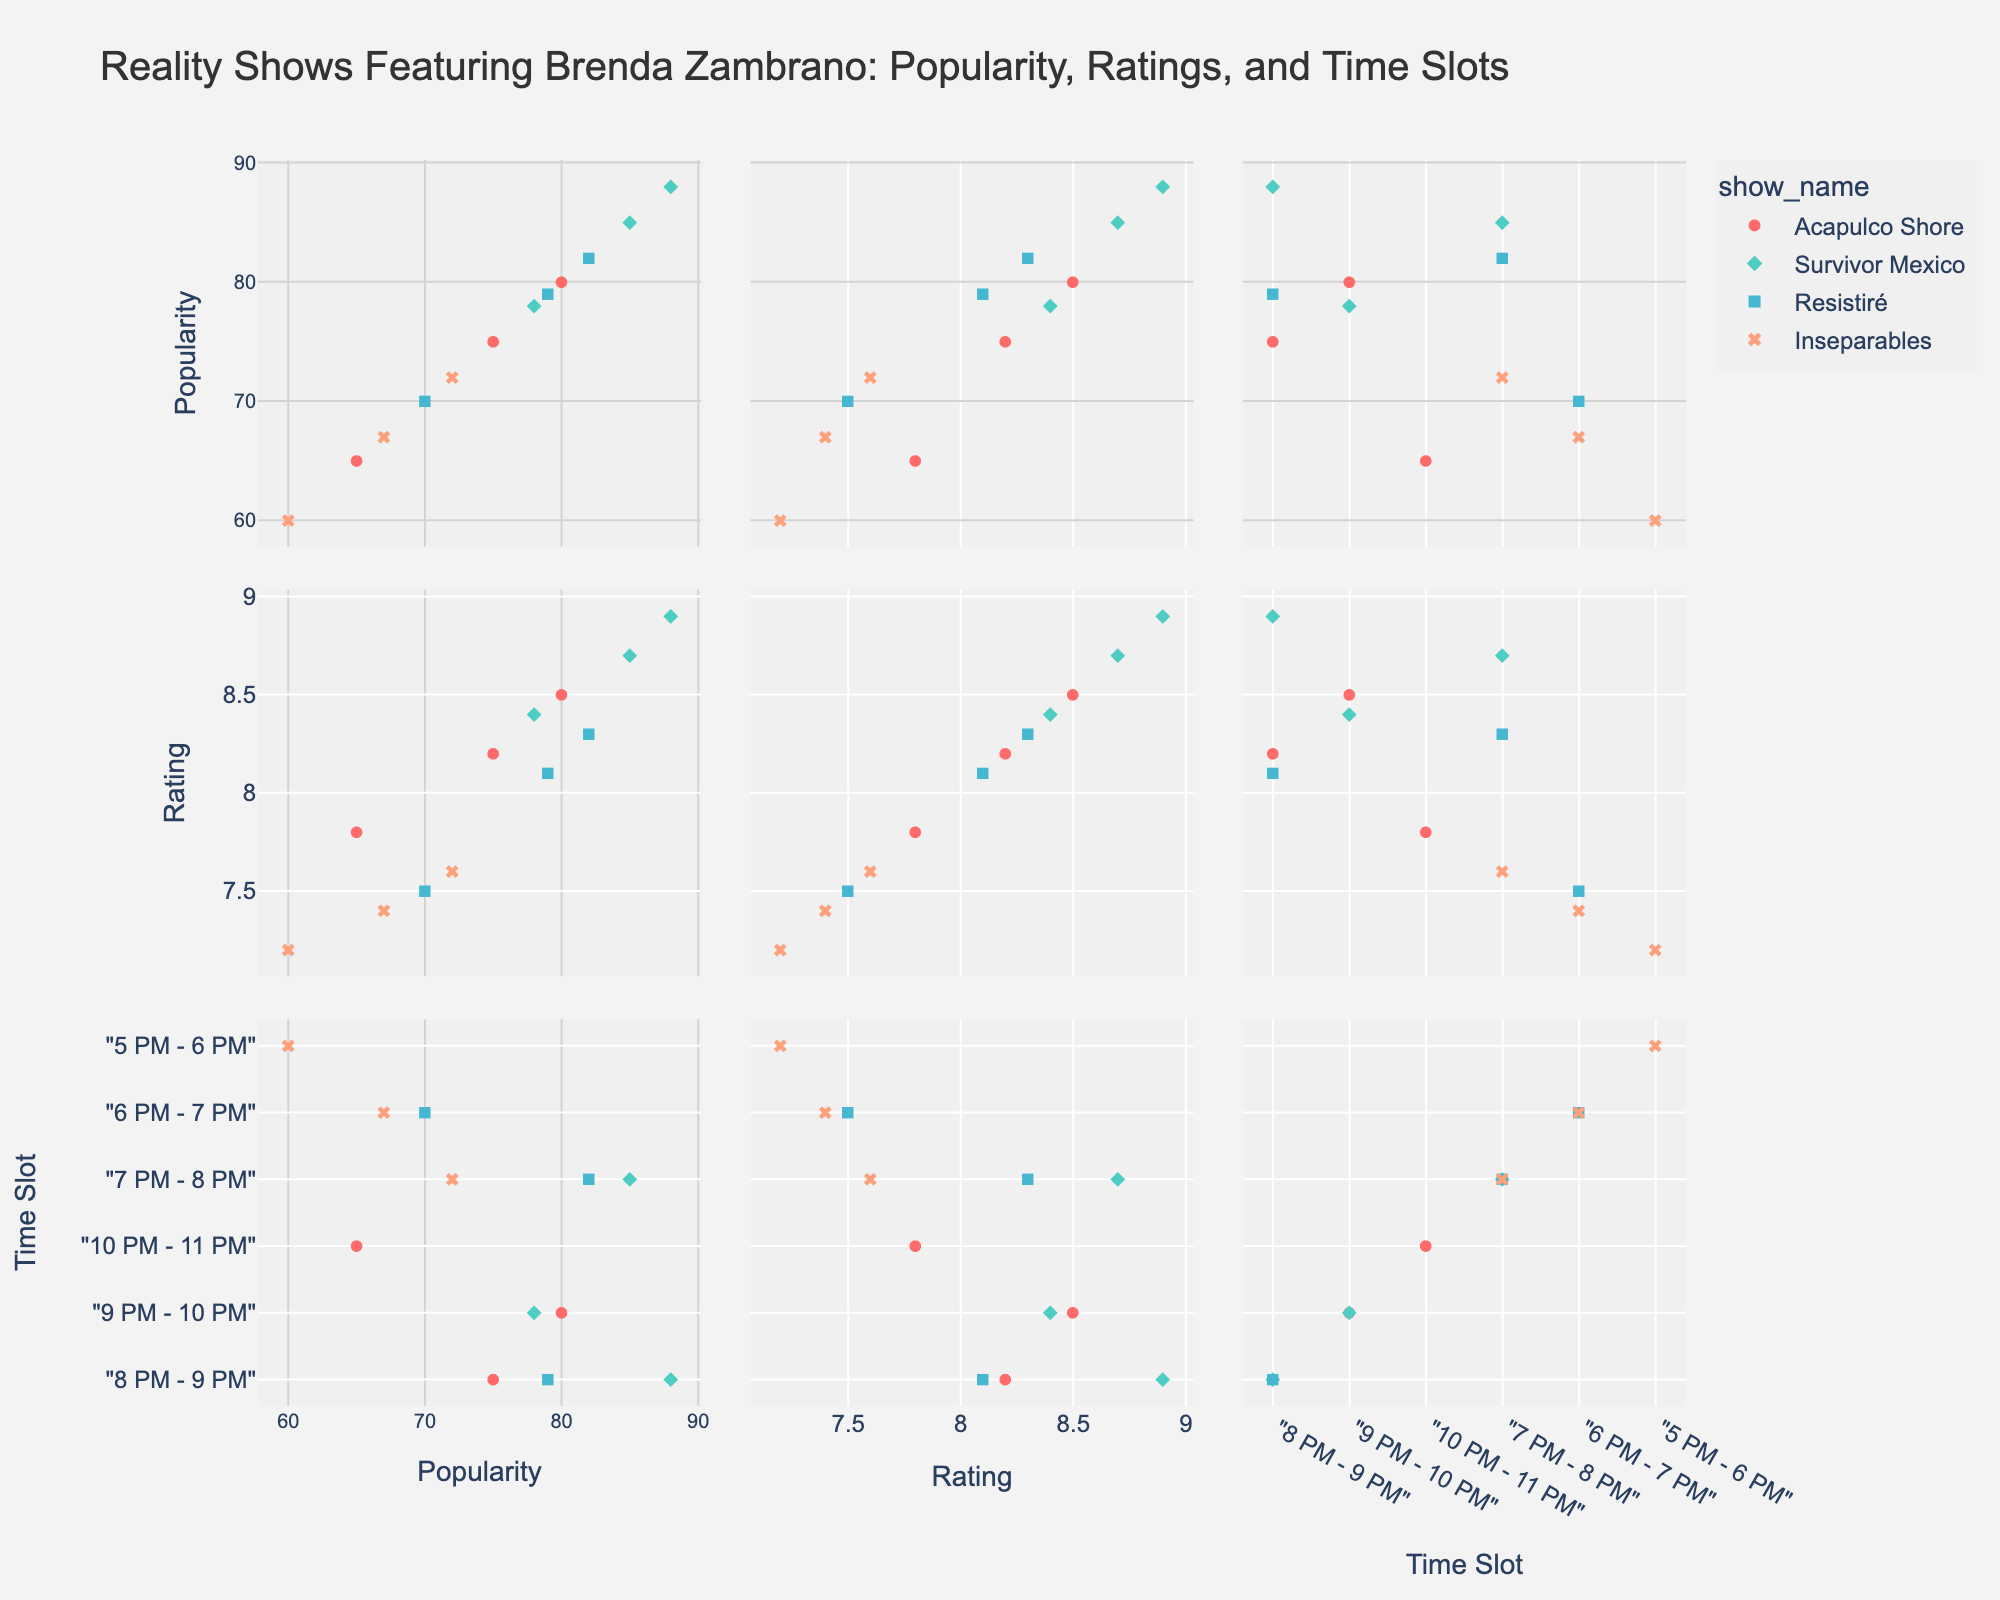what is the most popular time slot for "Survivor Mexico"? By looking at the scatter plot matrix, you can identify different time slots and their associated popularity for "Survivor Mexico". The data points for "Survivor Mexico" are distinguishable by their color. By finding the highest value of popularity among these points, we see that the most popular time slot is "8 PM - 9 PM" with a popularity score of 88.
Answer: 8 PM - 9 PM How does the rating of "Inseparables" at 5 PM - 6 PM compare to its ratings at later time slots? To answer this question, look at the data points representing "Inseparables". At 5 PM - 6 PM, the rating is 7.2. The ratings at later time slots are 7.4 (6 PM - 7 PM) and 7.6 (7 PM - 8 PM). Therefore, the rating increases at later time slots.
Answer: The rating increases Which show has the highest combined popularity and rating sum across all its time slots? Sum the popularity and rating for each show across all its time slots. "Acapulco Shore" has sums of 75+80+65 and 8.2+8.5+7.8, equaling a total of 230 and 24.5. "Survivor Mexico" has 85+88+78 and 8.7+8.9+8.4, equaling 251 and 26. "Resistiré" has 70+82+79 and 7.5+8.3+8.1, equaling 231 and 23.9. "Inseparables" has 60+67+72 and 7.2+7.4+7.6, equaling 199 and 22.2. Thus, "Survivor Mexico" has the highest combined sum.
Answer: Survivor Mexico What trend do you observe in the popularity of "Acapulco Shore" across its time slots? By examining the data points related to "Acapulco Shore", the popularity scores at different time slots are 75, 80, and 65. From 8 PM to 9 PM, the popularity increases from 75 to 80, but then drops to 65 from 10 PM to 11 PM. The trend shows an initial increase followed by a decrease.
Answer: Initially increases, then decreases Which time slot shows the highest rating for "Resistiré" and what is that rating? Locate the points for "Resistiré" and identify their respective ratings. The time slots are 6 PM - 7 PM, 7 PM - 8 PM, and 8 PM - 9 PM, with corresponding ratings of 7.5, 8.3, and 8.1. The highest rating is 8.3, which occurs during the 7 PM - 8 PM time slot.
Answer: 7 PM - 8 PM, 8.3 Are the popularities of "Inseparables" and "Survivor Mexico" at 7 PM - 8 PM close to each other? Find the popularity values for "Inseparables" and "Survivor Mexico" at the 7 PM - 8 PM time slot. "Inseparables" has a popularity of 72, while "Survivor Mexico" has 85. Therefore, the popularities are not close to each other, with "Survivor Mexico" having a significantly higher popularity.
Answer: No, they are not close What is the average rating of "Resistiré" over its time slots? The ratings of "Resistiré" at different time slots are 7.5, 8.3, and 8.1. To find the average, sum these values and divide by the number of time slots: (7.5 + 8.3 + 8.1) / 3 = 23.9 / 3 = 7.97.
Answer: 7.97 Which show has a rating exactly equal to 7.4 and during which time slot? Check the ratings on the figure to find a rating of 7.4. "Inseparables" has a rating of 7.4 during the 6 PM - 7 PM time slot.
Answer: Inseparables, 6 PM - 7 PM What show and time slot combination has the lowest rating and what is this rating? Identify the lowest rating among all data points. The lowest rating displayed is 7.2, which is associated with "Inseparables" during the 5 PM - 6 PM time slot.
Answer: Inseparables, 5 PM - 6 PM, 7.2 